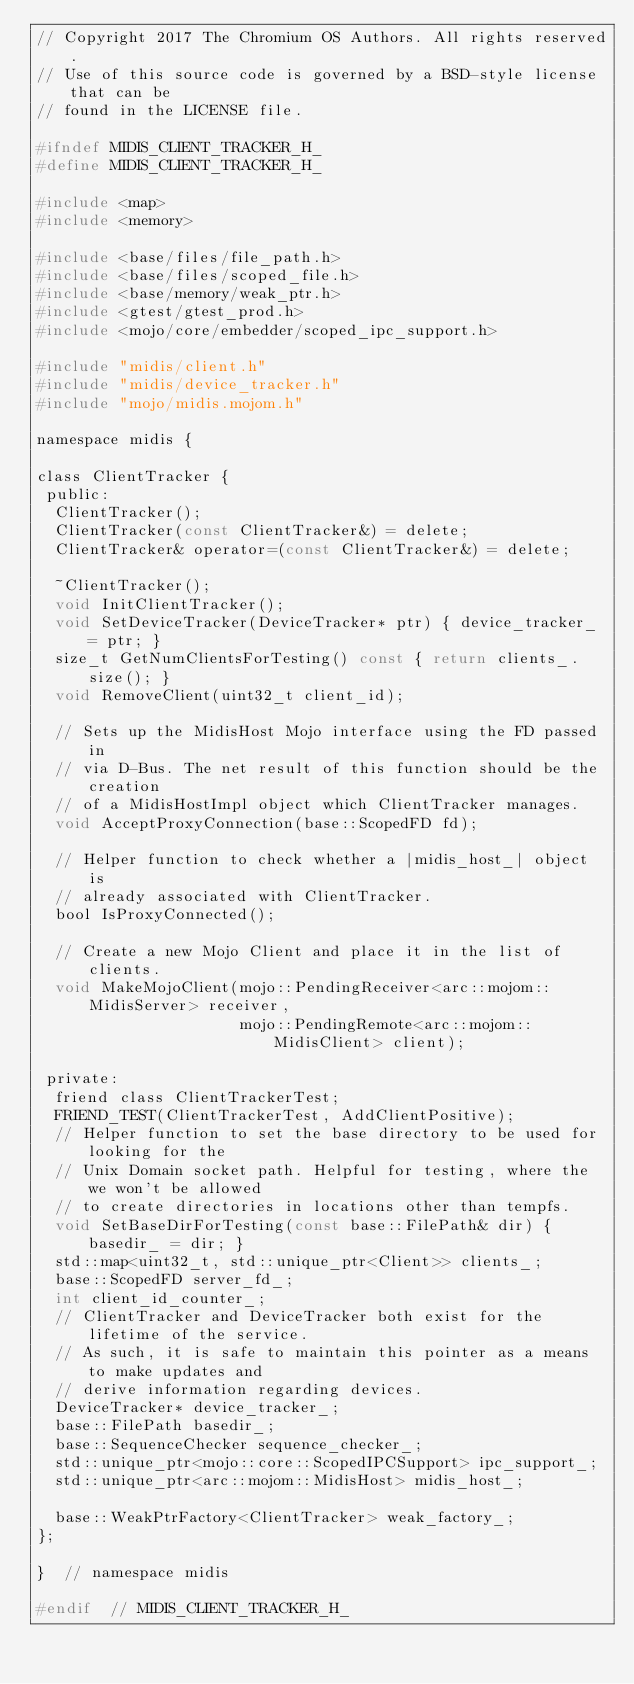Convert code to text. <code><loc_0><loc_0><loc_500><loc_500><_C_>// Copyright 2017 The Chromium OS Authors. All rights reserved.
// Use of this source code is governed by a BSD-style license that can be
// found in the LICENSE file.

#ifndef MIDIS_CLIENT_TRACKER_H_
#define MIDIS_CLIENT_TRACKER_H_

#include <map>
#include <memory>

#include <base/files/file_path.h>
#include <base/files/scoped_file.h>
#include <base/memory/weak_ptr.h>
#include <gtest/gtest_prod.h>
#include <mojo/core/embedder/scoped_ipc_support.h>

#include "midis/client.h"
#include "midis/device_tracker.h"
#include "mojo/midis.mojom.h"

namespace midis {

class ClientTracker {
 public:
  ClientTracker();
  ClientTracker(const ClientTracker&) = delete;
  ClientTracker& operator=(const ClientTracker&) = delete;

  ~ClientTracker();
  void InitClientTracker();
  void SetDeviceTracker(DeviceTracker* ptr) { device_tracker_ = ptr; }
  size_t GetNumClientsForTesting() const { return clients_.size(); }
  void RemoveClient(uint32_t client_id);

  // Sets up the MidisHost Mojo interface using the FD passed in
  // via D-Bus. The net result of this function should be the creation
  // of a MidisHostImpl object which ClientTracker manages.
  void AcceptProxyConnection(base::ScopedFD fd);

  // Helper function to check whether a |midis_host_| object is
  // already associated with ClientTracker.
  bool IsProxyConnected();

  // Create a new Mojo Client and place it in the list of clients.
  void MakeMojoClient(mojo::PendingReceiver<arc::mojom::MidisServer> receiver,
                      mojo::PendingRemote<arc::mojom::MidisClient> client);

 private:
  friend class ClientTrackerTest;
  FRIEND_TEST(ClientTrackerTest, AddClientPositive);
  // Helper function to set the base directory to be used for looking for the
  // Unix Domain socket path. Helpful for testing, where the we won't be allowed
  // to create directories in locations other than tempfs.
  void SetBaseDirForTesting(const base::FilePath& dir) { basedir_ = dir; }
  std::map<uint32_t, std::unique_ptr<Client>> clients_;
  base::ScopedFD server_fd_;
  int client_id_counter_;
  // ClientTracker and DeviceTracker both exist for the lifetime of the service.
  // As such, it is safe to maintain this pointer as a means to make updates and
  // derive information regarding devices.
  DeviceTracker* device_tracker_;
  base::FilePath basedir_;
  base::SequenceChecker sequence_checker_;
  std::unique_ptr<mojo::core::ScopedIPCSupport> ipc_support_;
  std::unique_ptr<arc::mojom::MidisHost> midis_host_;

  base::WeakPtrFactory<ClientTracker> weak_factory_;
};

}  // namespace midis

#endif  // MIDIS_CLIENT_TRACKER_H_
</code> 